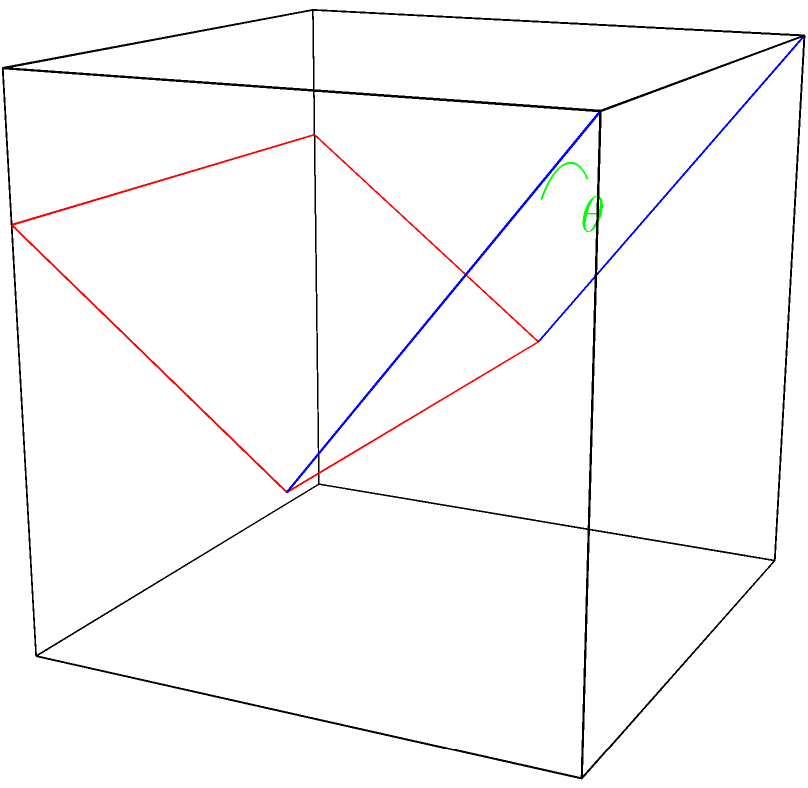Y'all know how we love our outdoor gatherings here in Austin! Now, imagine you're setting up for a backyard barbecue and you've got one of them folding chairs. The seat of the chair forms one plane, and the backrest forms another. If the angle between these two planes is 120°, what's the complement of this angle? Let's use our Texas-sized brains to figure this out! Alright, let's break this down step by step, just like we'd prep for a good ol' barbecue:

1) First, let's recall what a complement angle is. It's the angle that, when added to the original angle, gives us 90°.

2) We're told that the angle between the seat and the backrest is 120°. Let's call this angle $\theta$.

3) To find the complement, we need to subtract this angle from 90°:

   Complement = $90° - \theta$

4) Plugging in our value:

   Complement = $90° - 120°$

5) Now, let's do the math:

   Complement = $-30°$

6) However, in geometry, we typically express angles as positive values. So, we take the absolute value:

   Complement = $|{-30°}| = 30°$

So, just like how we always make sure there's enough room between the grill and the seating area, we've found the space between our angle and 90°!
Answer: 30° 